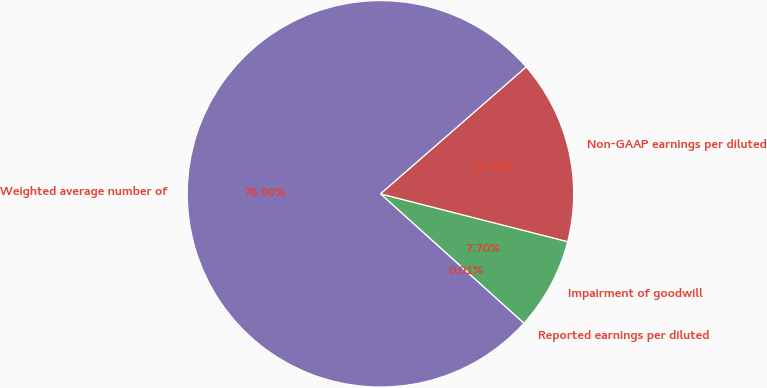Convert chart to OTSL. <chart><loc_0><loc_0><loc_500><loc_500><pie_chart><fcel>Reported earnings per diluted<fcel>Impairment of goodwill<fcel>Non-GAAP earnings per diluted<fcel>Weighted average number of<nl><fcel>0.01%<fcel>7.7%<fcel>15.39%<fcel>76.91%<nl></chart> 